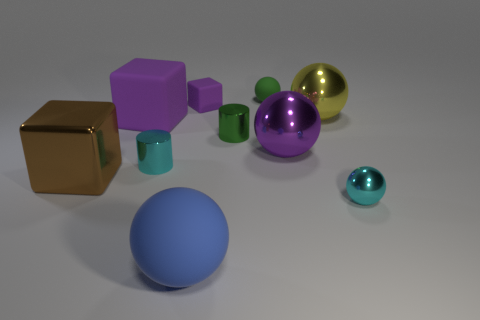Subtract all small rubber cubes. How many cubes are left? 2 Subtract all green balls. How many purple cubes are left? 2 Subtract all blue balls. How many balls are left? 4 Subtract all cyan cubes. Subtract all blue cylinders. How many cubes are left? 3 Subtract all cubes. How many objects are left? 7 Subtract all big blue matte objects. Subtract all purple metallic balls. How many objects are left? 8 Add 2 large rubber balls. How many large rubber balls are left? 3 Add 1 large rubber things. How many large rubber things exist? 3 Subtract 1 purple blocks. How many objects are left? 9 